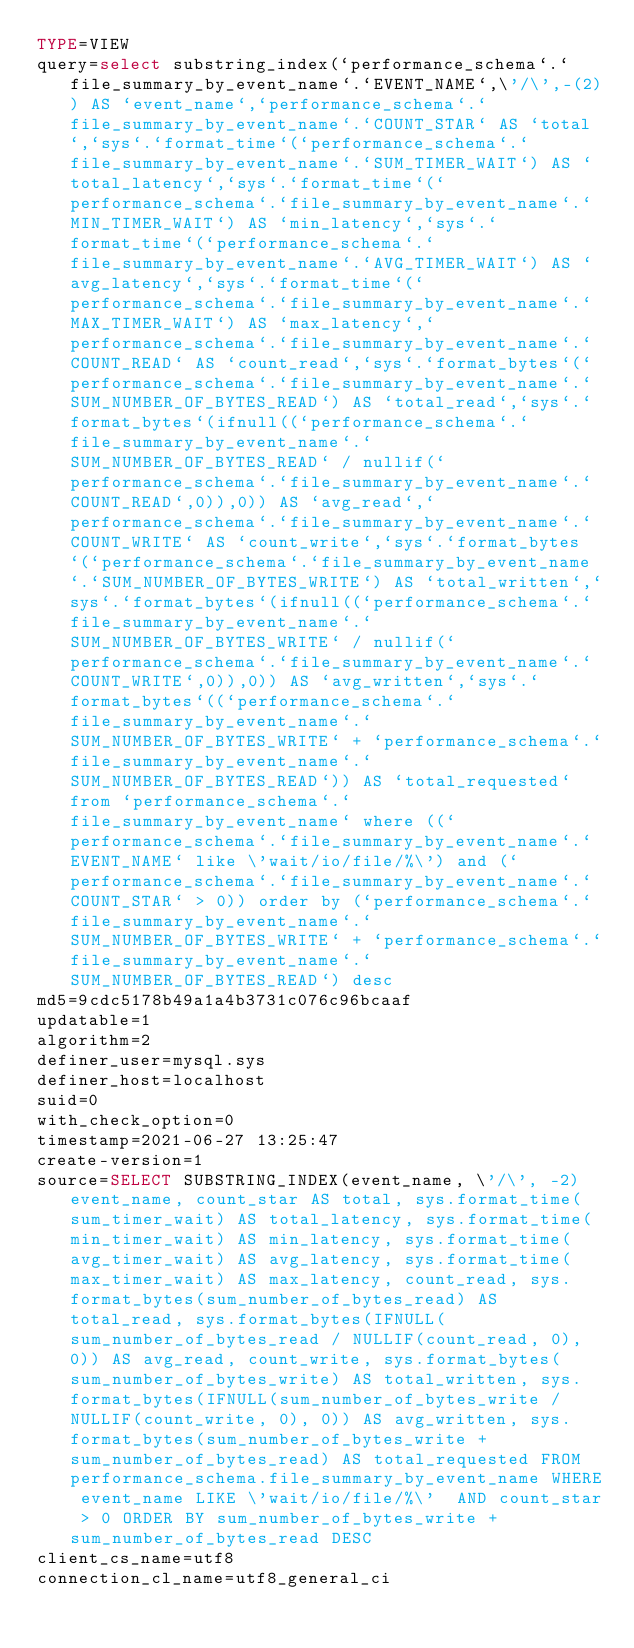<code> <loc_0><loc_0><loc_500><loc_500><_VisualBasic_>TYPE=VIEW
query=select substring_index(`performance_schema`.`file_summary_by_event_name`.`EVENT_NAME`,\'/\',-(2)) AS `event_name`,`performance_schema`.`file_summary_by_event_name`.`COUNT_STAR` AS `total`,`sys`.`format_time`(`performance_schema`.`file_summary_by_event_name`.`SUM_TIMER_WAIT`) AS `total_latency`,`sys`.`format_time`(`performance_schema`.`file_summary_by_event_name`.`MIN_TIMER_WAIT`) AS `min_latency`,`sys`.`format_time`(`performance_schema`.`file_summary_by_event_name`.`AVG_TIMER_WAIT`) AS `avg_latency`,`sys`.`format_time`(`performance_schema`.`file_summary_by_event_name`.`MAX_TIMER_WAIT`) AS `max_latency`,`performance_schema`.`file_summary_by_event_name`.`COUNT_READ` AS `count_read`,`sys`.`format_bytes`(`performance_schema`.`file_summary_by_event_name`.`SUM_NUMBER_OF_BYTES_READ`) AS `total_read`,`sys`.`format_bytes`(ifnull((`performance_schema`.`file_summary_by_event_name`.`SUM_NUMBER_OF_BYTES_READ` / nullif(`performance_schema`.`file_summary_by_event_name`.`COUNT_READ`,0)),0)) AS `avg_read`,`performance_schema`.`file_summary_by_event_name`.`COUNT_WRITE` AS `count_write`,`sys`.`format_bytes`(`performance_schema`.`file_summary_by_event_name`.`SUM_NUMBER_OF_BYTES_WRITE`) AS `total_written`,`sys`.`format_bytes`(ifnull((`performance_schema`.`file_summary_by_event_name`.`SUM_NUMBER_OF_BYTES_WRITE` / nullif(`performance_schema`.`file_summary_by_event_name`.`COUNT_WRITE`,0)),0)) AS `avg_written`,`sys`.`format_bytes`((`performance_schema`.`file_summary_by_event_name`.`SUM_NUMBER_OF_BYTES_WRITE` + `performance_schema`.`file_summary_by_event_name`.`SUM_NUMBER_OF_BYTES_READ`)) AS `total_requested` from `performance_schema`.`file_summary_by_event_name` where ((`performance_schema`.`file_summary_by_event_name`.`EVENT_NAME` like \'wait/io/file/%\') and (`performance_schema`.`file_summary_by_event_name`.`COUNT_STAR` > 0)) order by (`performance_schema`.`file_summary_by_event_name`.`SUM_NUMBER_OF_BYTES_WRITE` + `performance_schema`.`file_summary_by_event_name`.`SUM_NUMBER_OF_BYTES_READ`) desc
md5=9cdc5178b49a1a4b3731c076c96bcaaf
updatable=1
algorithm=2
definer_user=mysql.sys
definer_host=localhost
suid=0
with_check_option=0
timestamp=2021-06-27 13:25:47
create-version=1
source=SELECT SUBSTRING_INDEX(event_name, \'/\', -2) event_name, count_star AS total, sys.format_time(sum_timer_wait) AS total_latency, sys.format_time(min_timer_wait) AS min_latency, sys.format_time(avg_timer_wait) AS avg_latency, sys.format_time(max_timer_wait) AS max_latency, count_read, sys.format_bytes(sum_number_of_bytes_read) AS total_read, sys.format_bytes(IFNULL(sum_number_of_bytes_read / NULLIF(count_read, 0), 0)) AS avg_read, count_write, sys.format_bytes(sum_number_of_bytes_write) AS total_written, sys.format_bytes(IFNULL(sum_number_of_bytes_write / NULLIF(count_write, 0), 0)) AS avg_written, sys.format_bytes(sum_number_of_bytes_write + sum_number_of_bytes_read) AS total_requested FROM performance_schema.file_summary_by_event_name WHERE event_name LIKE \'wait/io/file/%\'  AND count_star > 0 ORDER BY sum_number_of_bytes_write + sum_number_of_bytes_read DESC
client_cs_name=utf8
connection_cl_name=utf8_general_ci</code> 